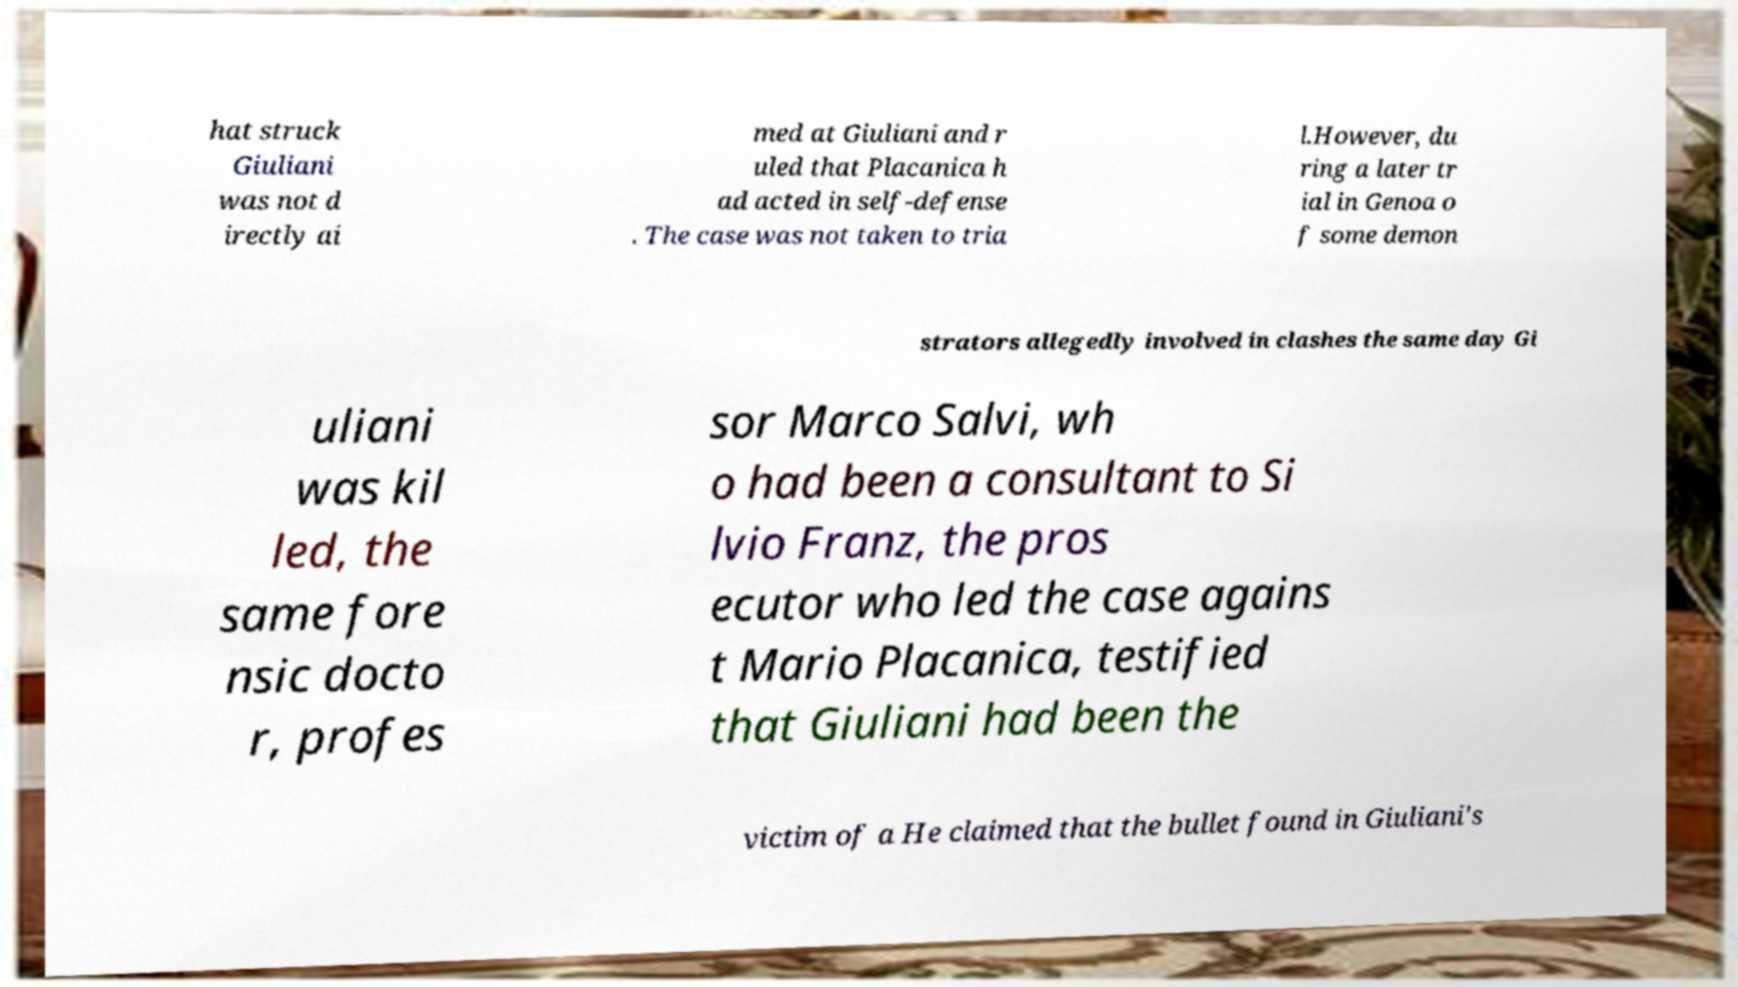For documentation purposes, I need the text within this image transcribed. Could you provide that? hat struck Giuliani was not d irectly ai med at Giuliani and r uled that Placanica h ad acted in self-defense . The case was not taken to tria l.However, du ring a later tr ial in Genoa o f some demon strators allegedly involved in clashes the same day Gi uliani was kil led, the same fore nsic docto r, profes sor Marco Salvi, wh o had been a consultant to Si lvio Franz, the pros ecutor who led the case agains t Mario Placanica, testified that Giuliani had been the victim of a He claimed that the bullet found in Giuliani's 